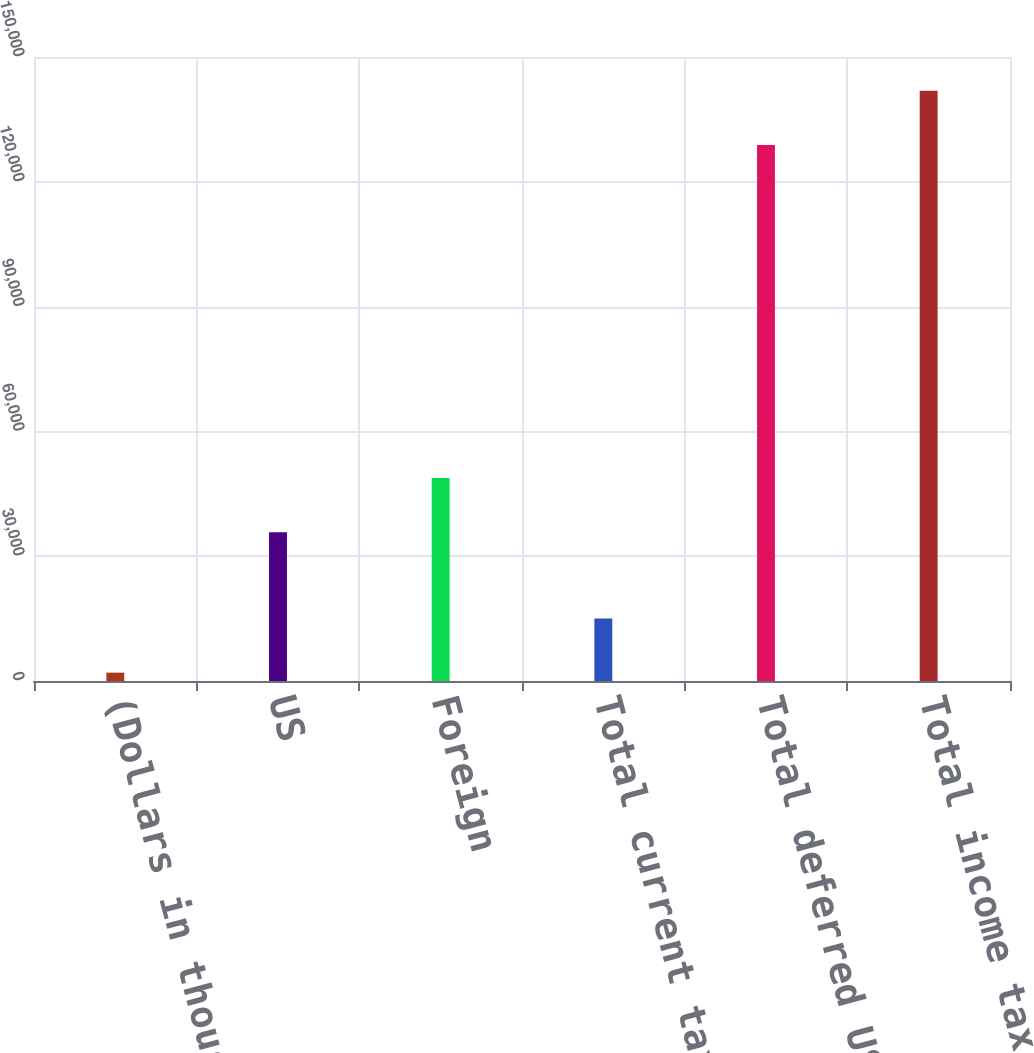Convert chart to OTSL. <chart><loc_0><loc_0><loc_500><loc_500><bar_chart><fcel>(Dollars in thousands)<fcel>US<fcel>Foreign<fcel>Total current tax expense<fcel>Total deferred US tax expense<fcel>Total income tax expense<nl><fcel>2009<fcel>35739<fcel>48771.3<fcel>15041.3<fcel>128851<fcel>141883<nl></chart> 